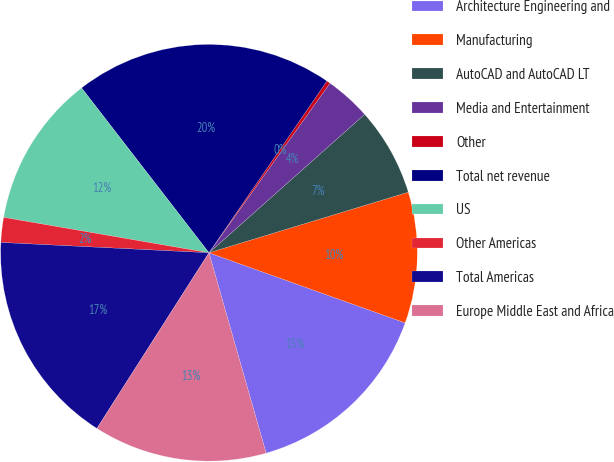<chart> <loc_0><loc_0><loc_500><loc_500><pie_chart><fcel>Architecture Engineering and<fcel>Manufacturing<fcel>AutoCAD and AutoCAD LT<fcel>Media and Entertainment<fcel>Other<fcel>Total net revenue<fcel>US<fcel>Other Americas<fcel>Total Americas<fcel>Europe Middle East and Africa<nl><fcel>15.11%<fcel>10.16%<fcel>6.87%<fcel>3.57%<fcel>0.28%<fcel>20.05%<fcel>11.81%<fcel>1.93%<fcel>16.75%<fcel>13.46%<nl></chart> 